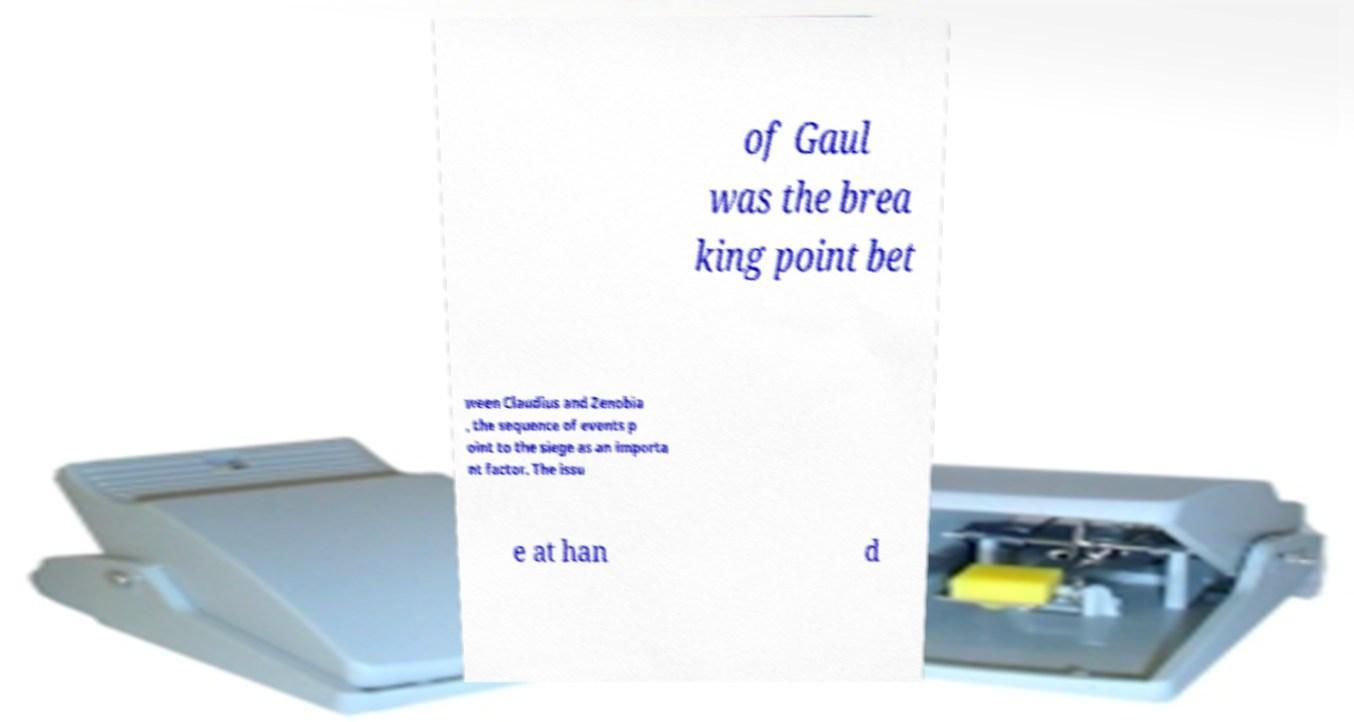Can you accurately transcribe the text from the provided image for me? of Gaul was the brea king point bet ween Claudius and Zenobia , the sequence of events p oint to the siege as an importa nt factor. The issu e at han d 